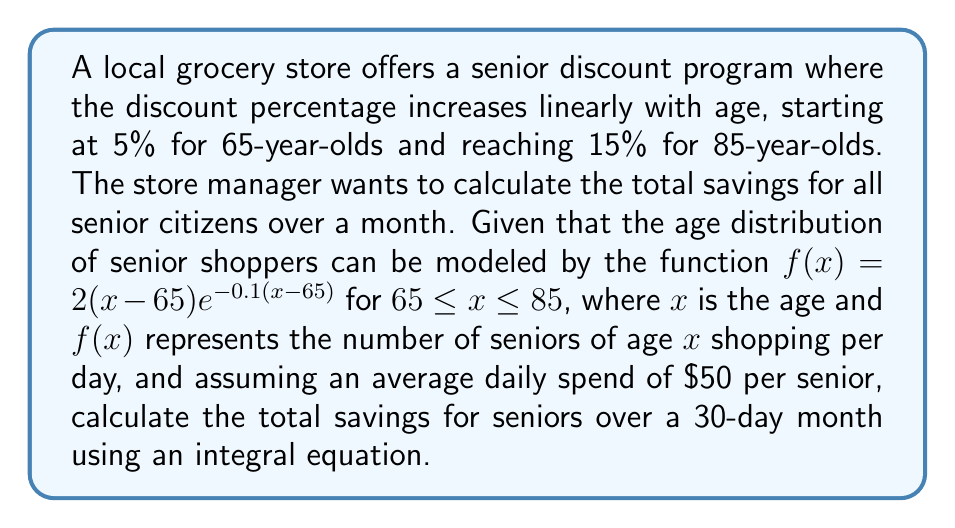Can you solve this math problem? Let's approach this step-by-step:

1) First, we need to define the discount function. It increases linearly from 5% at 65 to 15% at 85:

   $d(x) = 0.05 + \frac{0.15 - 0.05}{85 - 65}(x - 65) = 0.05 + 0.005(x - 65)$

2) The savings for a single senior of age $x$ per day is:

   $50 \cdot d(x) = 50(0.05 + 0.005(x - 65)) = 2.5 + 0.25(x - 65)$

3) To get the total savings per day, we need to integrate this over all ages, weighted by the number of seniors of each age:

   $S = \int_{65}^{85} [2.5 + 0.25(x - 65)] \cdot 2(x-65)e^{-0.1(x-65)} dx$

4) Expanding this:

   $S = \int_{65}^{85} [5(x-65)e^{-0.1(x-65)} + 0.5(x-65)^2e^{-0.1(x-65)}] dx$

5) This integral can be solved using integration by parts. Let $u = (x-65)$ and $u^2$, and $dv = e^{-0.1(x-65)}dx$ for the two terms respectively. After solving:

   $S = [-50e^{-0.1(x-65)} - 15(x-65)e^{-0.1(x-65)} - 5(x-65)^2e^{-0.1(x-65)}]_{65}^{85}$

6) Evaluating at the limits:

   $S = [-50e^{-2} - 15(20)e^{-2} - 5(400)e^{-2}] - [-50 - 0 - 0] = 50 - 6.767 = 43.233$

7) This is the savings per day. For a 30-day month:

   Total Savings = $30 \cdot 43.233 = 1296.99$
Answer: $1296.99 